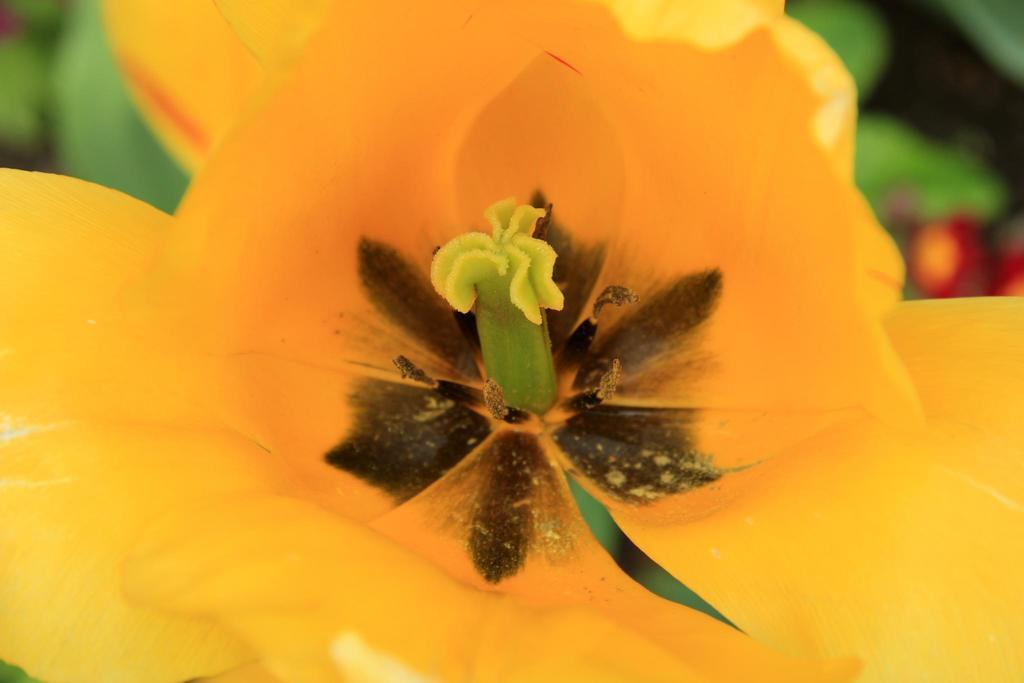What is the main subject in the front of the image? There is a flower in the front of the image. Can you describe the background of the image? The background of the image is blurry. Can you tell me how many giraffes are walking in the box in the image? There are no giraffes or boxes present in the image; it features a flower with a blurry background. 